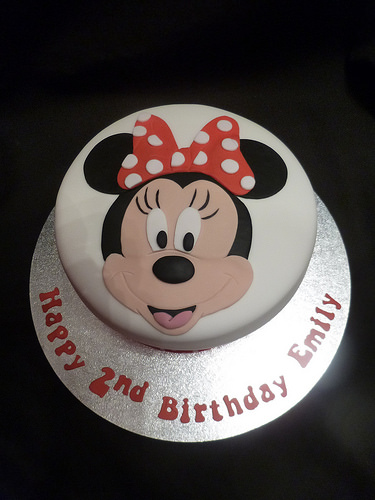<image>
Is there a bow under the mouse? No. The bow is not positioned under the mouse. The vertical relationship between these objects is different. 